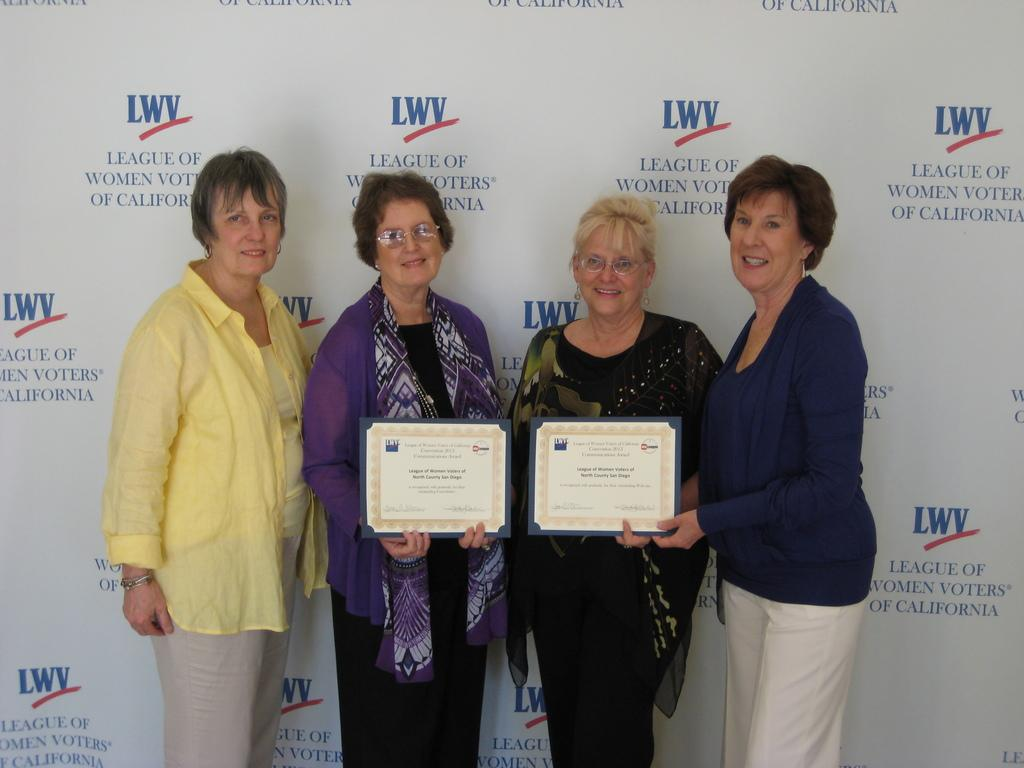How many people are in the image? There are four persons standing in the middle of the image. What are the persons holding in the image? The persons are holding two frames. What can be seen in the background of the image? There is a wall poster in the background. What type of bird is sitting on the person's shoulder in the image? There is no bird present in the image; the persons are holding two frames and standing in front of a wall poster. 